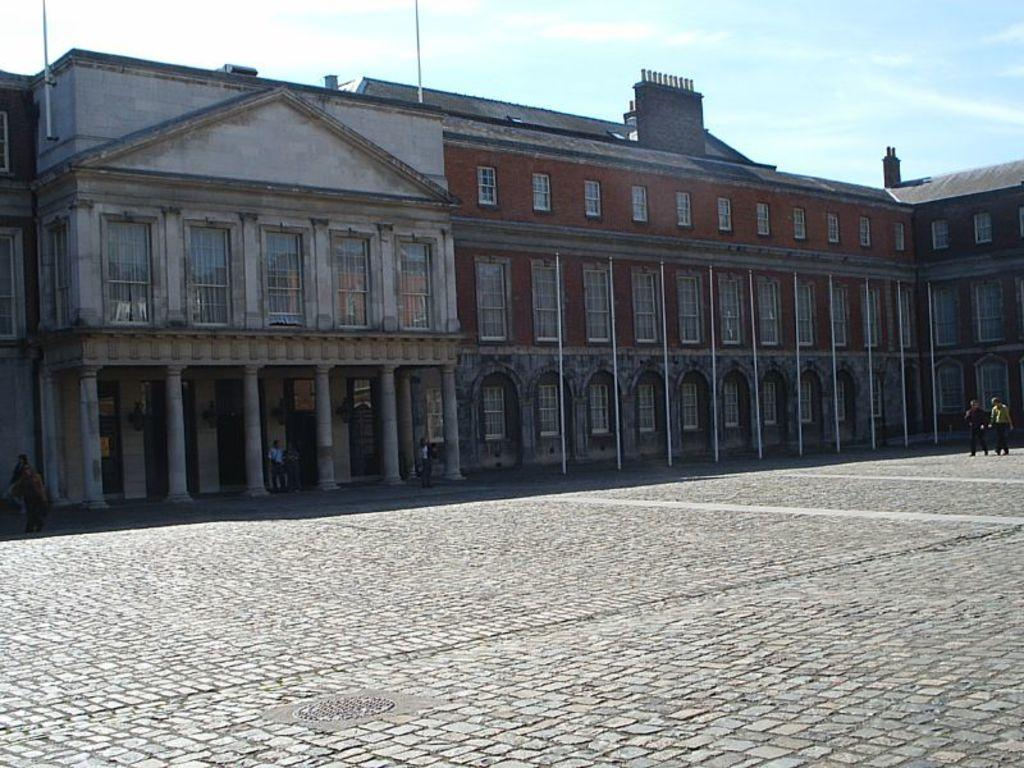What can be seen on the ground in the image? There are people on the ground in the image. What type of structure is present in the image? There is a building with windows in the image. What architectural feature is present on the building? The building has pillars. What are the tall, vertical objects in the image? There are poles in the image. What is visible in the background of the image? The sky is visible in the background of the image. How many ducks are flying in the process depicted in the image? There are no ducks or any process involving ducks present in the image. 